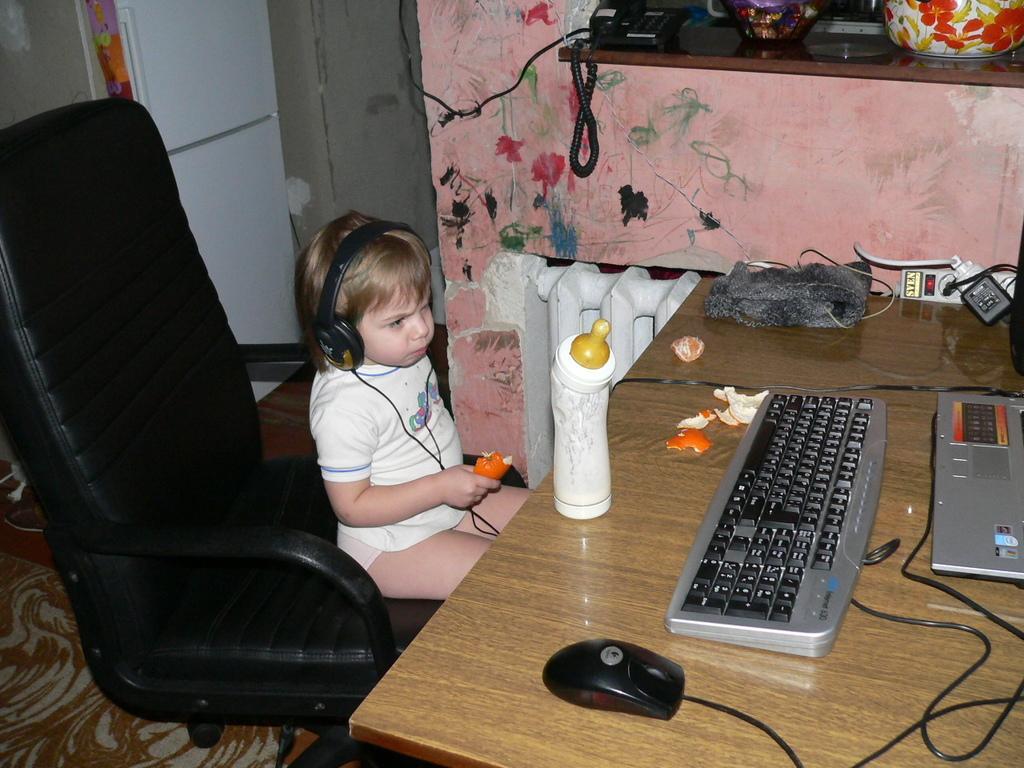Please provide a concise description of this image. This is a picture in living room. In the picture on the right there is a table, on the table there is a laptop, a keyboard and a mouse and a bottle. In the center of the picture there is a chair in the there is a baby. In the background there is a desk, on the disk there are telephone, pots and utensils. In the right top there is a door and a closet. 